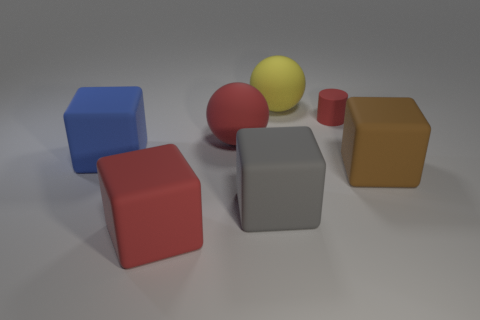There is a tiny red rubber thing; is its shape the same as the large matte thing that is to the left of the red block?
Offer a terse response. No. How many rubber things are either large yellow things or tiny objects?
Ensure brevity in your answer.  2. There is a ball behind the big red thing that is behind the red thing that is in front of the large brown cube; what is its color?
Offer a terse response. Yellow. How many other objects are there of the same material as the big red cube?
Ensure brevity in your answer.  6. Is the shape of the big red rubber object behind the gray matte object the same as  the big yellow thing?
Provide a short and direct response. Yes. How many tiny things are either gray cubes or red cylinders?
Provide a short and direct response. 1. Is the number of blue blocks right of the red cube the same as the number of blue blocks that are behind the red matte sphere?
Offer a terse response. Yes. What number of other things are there of the same color as the cylinder?
Ensure brevity in your answer.  2. Do the small cylinder and the large sphere that is left of the gray cube have the same color?
Make the answer very short. Yes. How many yellow things are either big matte cylinders or big things?
Your answer should be very brief. 1. 